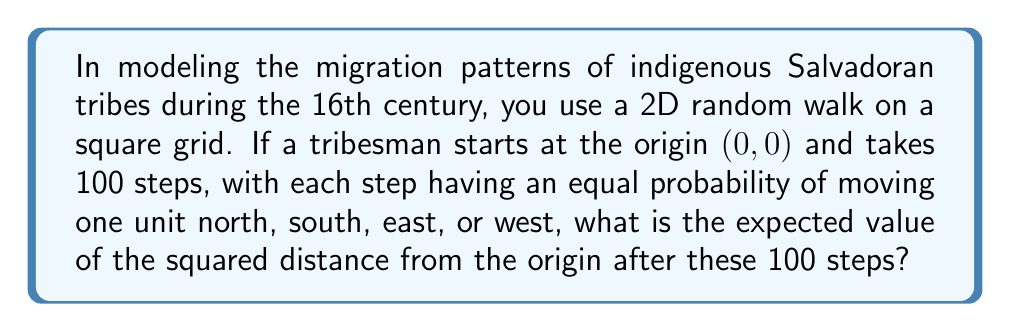Can you solve this math problem? To solve this problem, we'll use the properties of random walks and the linearity of expectation:

1) In a 2D random walk, the x and y coordinates are independent.

2) For each step, the expected change in x or y is 0, as there's an equal probability of moving +1 or -1 in each direction.

3) The squared distance from the origin after n steps is given by $X_n^2 + Y_n^2$, where $X_n$ and $Y_n$ are the x and y coordinates after n steps.

4) We need to find $E[X_n^2 + Y_n^2] = E[X_n^2] + E[Y_n^2]$ due to linearity of expectation.

5) For a 1D random walk, the expected value of the square of the position after n steps is n. This is because:
   $$E[X_n^2] = E[(X_{n-1} + \Delta X_n)^2] = E[X_{n-1}^2] + E[\Delta X_n^2] + 2E[X_{n-1}\Delta X_n]$$
   where $\Delta X_n$ is the nth step. $E[\Delta X_n^2] = 1$ and $E[X_{n-1}\Delta X_n] = 0$, so:
   $$E[X_n^2] = E[X_{n-1}^2] + 1$$
   Solving this recurrence with $E[X_0^2] = 0$, we get $E[X_n^2] = n$.

6) The same applies for $Y_n^2$, so $E[Y_n^2] = n$.

7) Therefore, $E[X_n^2 + Y_n^2] = E[X_n^2] + E[Y_n^2] = n + n = 2n$.

8) In this case, n = 100, so the expected squared distance is $2 * 100 = 200$.
Answer: 200 